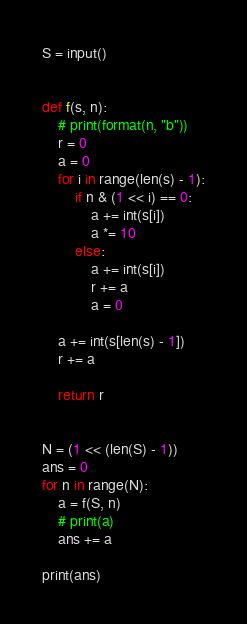Convert code to text. <code><loc_0><loc_0><loc_500><loc_500><_Python_>S = input()


def f(s, n):
    # print(format(n, "b"))
    r = 0
    a = 0
    for i in range(len(s) - 1):
        if n & (1 << i) == 0:
            a += int(s[i])
            a *= 10
        else:
            a += int(s[i])
            r += a
            a = 0

    a += int(s[len(s) - 1])
    r += a

    return r


N = (1 << (len(S) - 1))
ans = 0
for n in range(N):
    a = f(S, n)
    # print(a)
    ans += a

print(ans)
</code> 